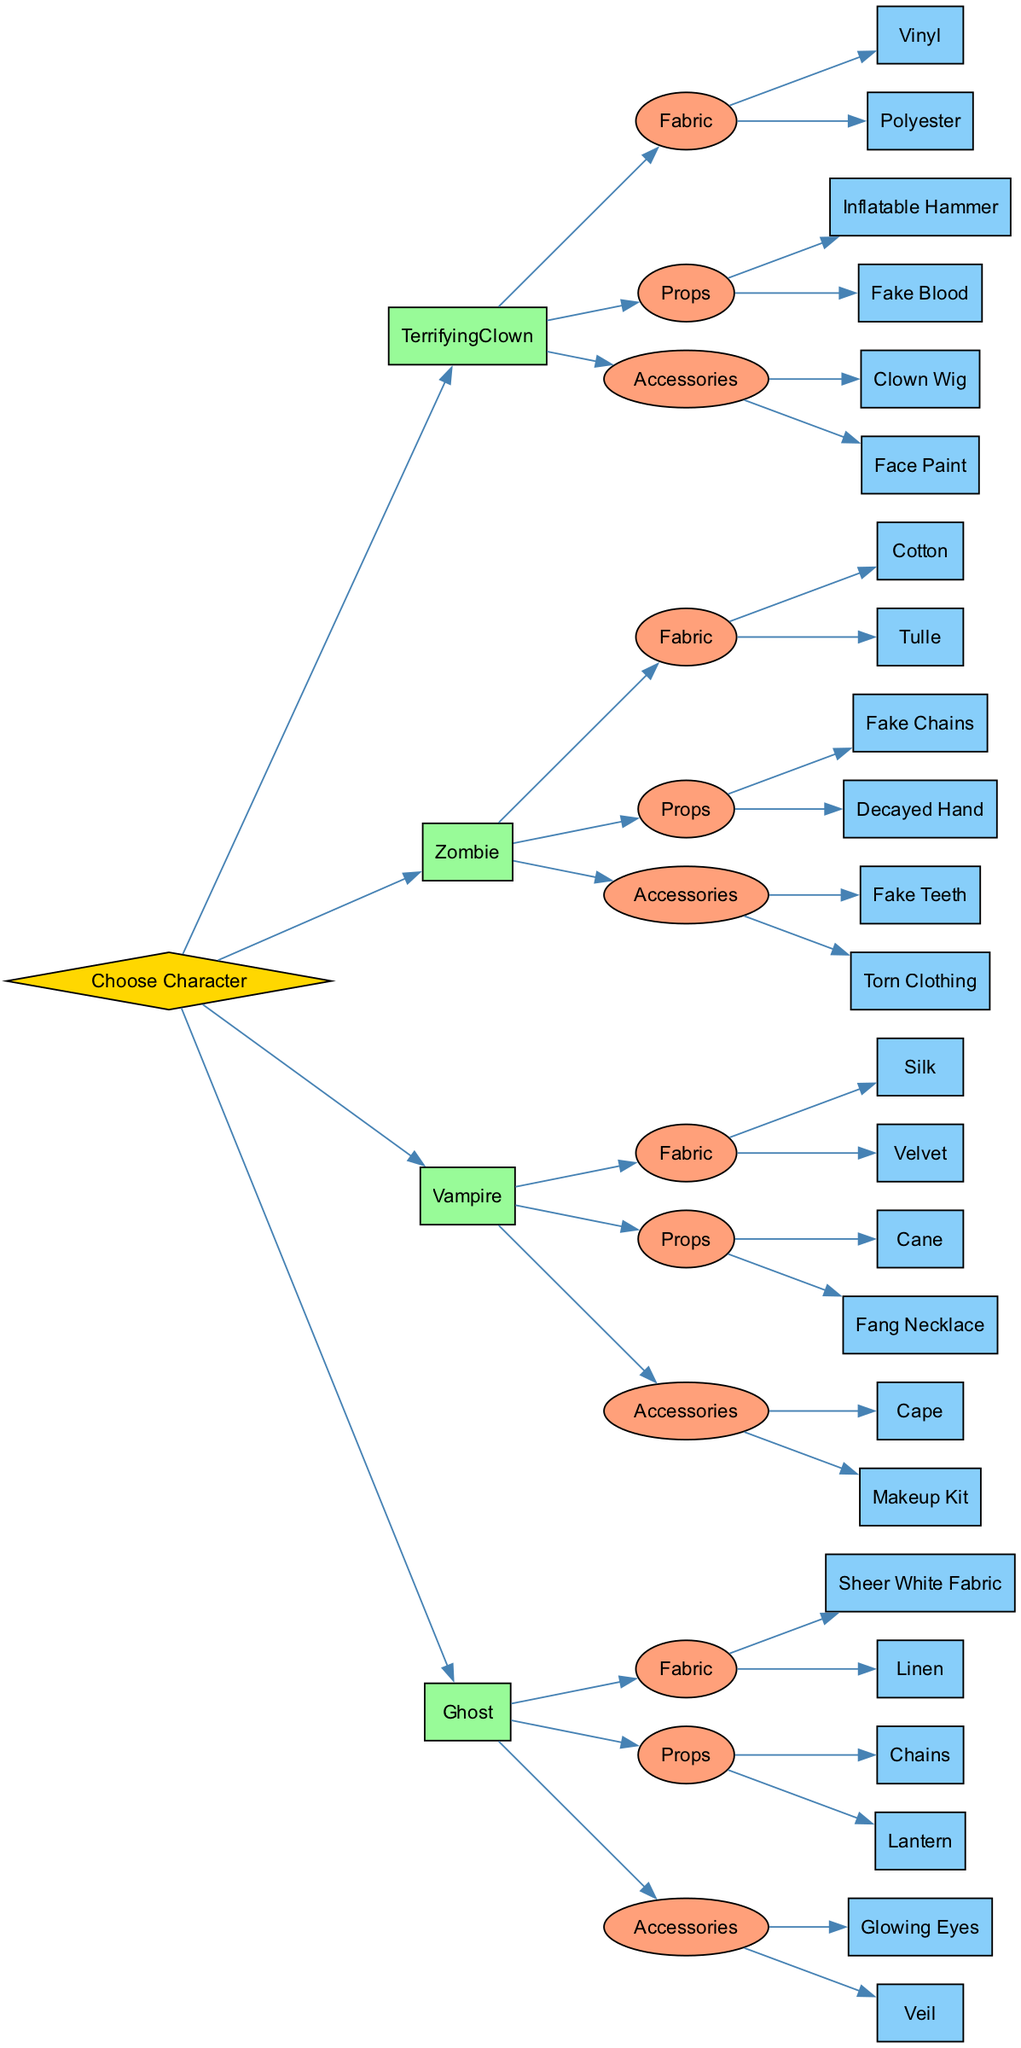What character options are available for selection? The diagram presents four character options to choose from: Terrifying Clown, Zombie, Vampire, and Ghost. These options are directly listed as the first layer of nodes under "Choose Character."
Answer: Terrifying Clown, Zombie, Vampire, Ghost How many options are listed for prop selection under the Vampire character? The Vampire character has two prop options listed beneath it in the diagram: Cane and Fang Necklace. This can be confirmed by counting the nodes connected directly from the Vampire's Props node.
Answer: 2 What material is suggested for the Ghost character's fabric? The diagram indicates two fabric options for the Ghost character: Sheer White Fabric and Linen. The answer is found by examining the Ghost's Fabric node.
Answer: Sheer White Fabric, Linen Which props can be selected for the Zombie character? For the Zombie character, the two available prop options are Fake Chains and Decayed Hand. These options can be identified in the decision tree under Zombie's Props node.
Answer: Fake Chains, Decayed Hand If the selected character is the Terrifying Clown, what accessory options are available? The decision tree lists two accessory options for the Terrifying Clown: Clown Wig and Face Paint. To find this, look under the Accessories node connected to the Terrifying Clown character.
Answer: Clown Wig, Face Paint Which character has a fabric option of Silk? The Vampire character has Silk as one of its fabric options. This can be determined by locating the Fabric node under the Vampire character and reading its options.
Answer: Vampire Which accessory corresponds with the Ghost character? The Ghost character can be accessorized with Glowing Eyes or a Veil. This information is found by looking at the Accessories node connecting to the Ghost character.
Answer: Glowing Eyes, Veil How many main character categories (Fabric, Props, Accessories) are included for each character in the diagram? Each character in the diagram includes three main categories: Fabric, Props, and Accessories. These categories are identical under every character node.
Answer: 3 What is the relationship between the Zombie character and Fake Teeth? Fake Teeth is categorized under Accessories for the Zombie character. The relationship can be observed by following the edge from the Zombie node to the Accessories node and then to the option Fake Teeth.
Answer: Accessories 